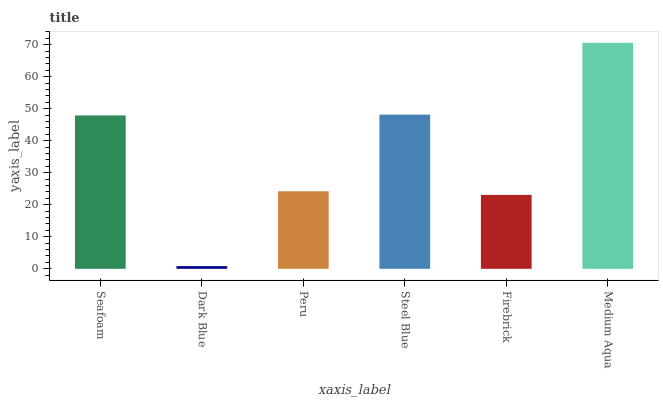Is Dark Blue the minimum?
Answer yes or no. Yes. Is Medium Aqua the maximum?
Answer yes or no. Yes. Is Peru the minimum?
Answer yes or no. No. Is Peru the maximum?
Answer yes or no. No. Is Peru greater than Dark Blue?
Answer yes or no. Yes. Is Dark Blue less than Peru?
Answer yes or no. Yes. Is Dark Blue greater than Peru?
Answer yes or no. No. Is Peru less than Dark Blue?
Answer yes or no. No. Is Seafoam the high median?
Answer yes or no. Yes. Is Peru the low median?
Answer yes or no. Yes. Is Dark Blue the high median?
Answer yes or no. No. Is Steel Blue the low median?
Answer yes or no. No. 